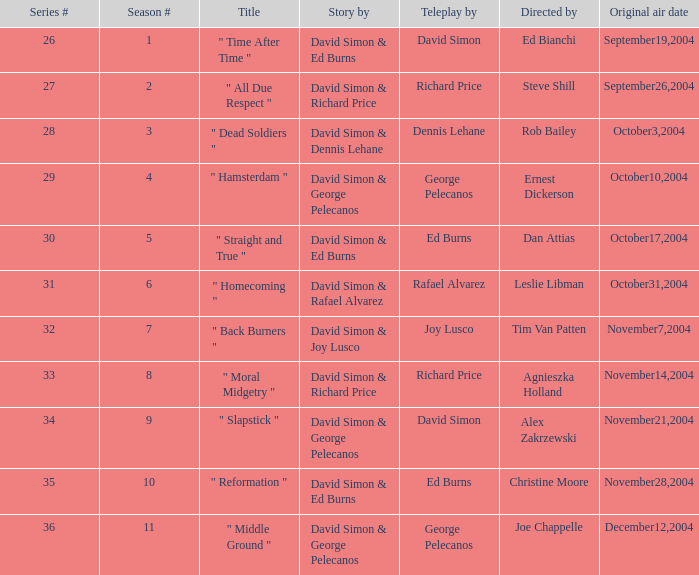What is the season # for a teleplay by Richard Price and the director is Steve Shill? 2.0. 